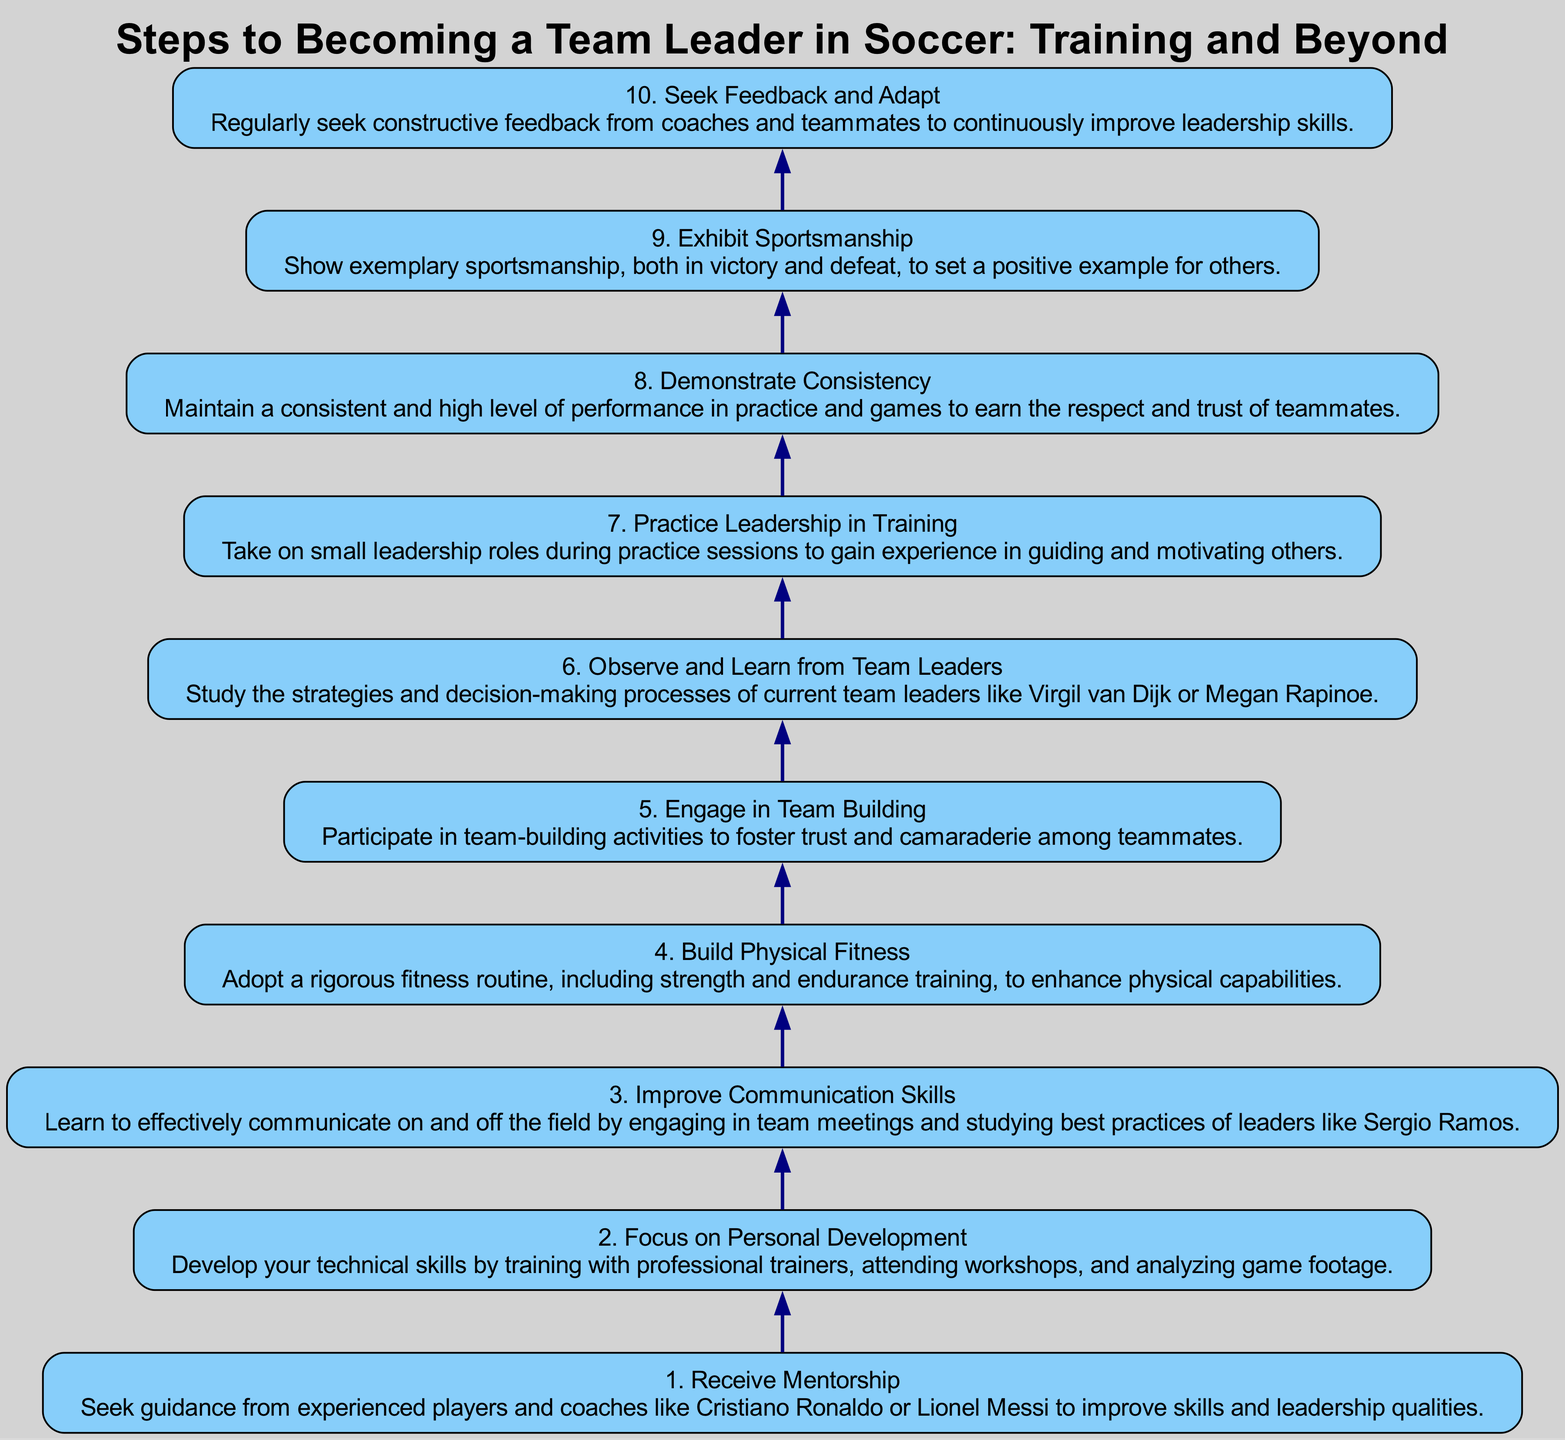What is the title of the top node in the diagram? The title of the top node, which represents the final step in the instruction flow, can be found in the label of the node with the highest level (level 10). It reads "Seek Feedback and Adapt."
Answer: Seek Feedback and Adapt How many steps are there in the diagram? By counting the nodes represented in the diagram, we can see there are a total of ten steps, ranging from level 1 to level 10, each representing a step toward becoming a team leader in soccer.
Answer: 10 Which step comes immediately before "Demonstrate Consistency"? To find the step that comes immediately before "Demonstrate Consistency," we need to identify the node labeled "Demonstrate Consistency" at level 8 and then look for the preceding node at level 7, which is "Practice Leadership in Training."
Answer: Practice Leadership in Training What is described in level 4 of the diagram? Level 4 of the diagram contains the details of the step titled "Build Physical Fitness." The description focuses on the need for a rigorous fitness routine, including strength and endurance training to enhance physical capabilities.
Answer: Build Physical Fitness How do the final two steps differ in their focus? The final two steps consist of "Exhibit Sportsmanship" at level 9 and "Seek Feedback and Adapt" at level 10. The former emphasizes the need to show sportsmanship in different match situations, while the latter stresses the importance of receiving constructive feedback for continuous improvement in leadership skills.
Answer: Sportsmanship vs. Feedback What is the primary action emphasized in level 1? In level 1, the primary action emphasized is "Receive Mentorship." This is about seeking guidance from experienced players and coaches to improve leadership qualities and skills.
Answer: Receive Mentorship Which step introduces the concept of team-building activities? The concept of team-building activities is introduced in level 5, where the step titled "Engage in Team Building" describes participation in activities designed to foster trust and camaraderie among teammates.
Answer: Engage in Team Building Identify one key figure mentioned in level 1 as a potential mentor. Level 1 mentions both Cristiano Ronaldo and Lionel Messi as examples of experienced players from whom one can seek mentorship to improve skills and leadership.
Answer: Cristiano Ronaldo What type of skills does level 3 focus on improving? Level 3 is dedicated to improving "Communication Skills," specifically pointing out the importance of effective communication on and off the field by engaging in team meetings.
Answer: Communication Skills 